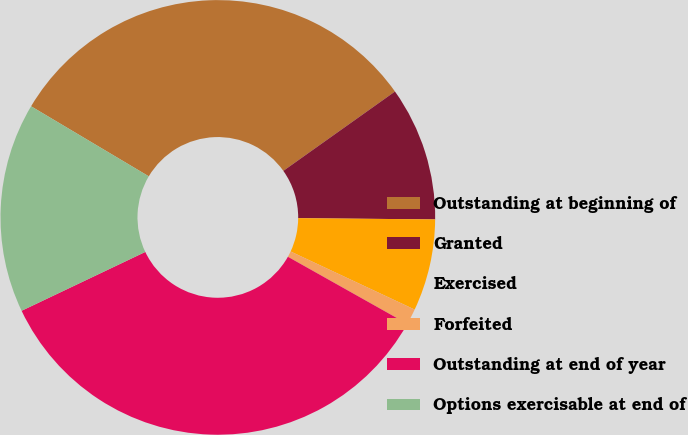<chart> <loc_0><loc_0><loc_500><loc_500><pie_chart><fcel>Outstanding at beginning of<fcel>Granted<fcel>Exercised<fcel>Forfeited<fcel>Outstanding at end of year<fcel>Options exercisable at end of<nl><fcel>31.62%<fcel>9.98%<fcel>6.82%<fcel>1.18%<fcel>34.78%<fcel>15.61%<nl></chart> 